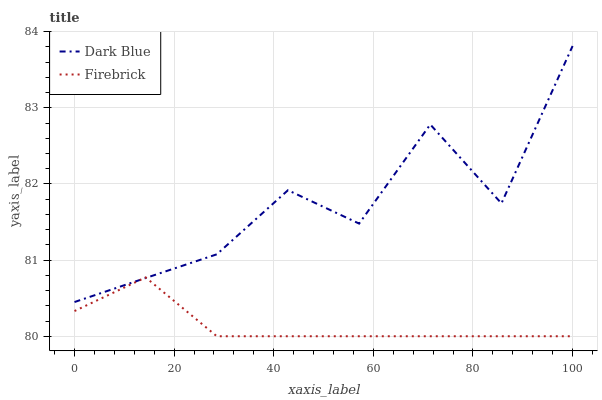Does Firebrick have the minimum area under the curve?
Answer yes or no. Yes. Does Dark Blue have the maximum area under the curve?
Answer yes or no. Yes. Does Firebrick have the maximum area under the curve?
Answer yes or no. No. Is Firebrick the smoothest?
Answer yes or no. Yes. Is Dark Blue the roughest?
Answer yes or no. Yes. Is Firebrick the roughest?
Answer yes or no. No. Does Firebrick have the lowest value?
Answer yes or no. Yes. Does Dark Blue have the highest value?
Answer yes or no. Yes. Does Firebrick have the highest value?
Answer yes or no. No. Does Dark Blue intersect Firebrick?
Answer yes or no. Yes. Is Dark Blue less than Firebrick?
Answer yes or no. No. Is Dark Blue greater than Firebrick?
Answer yes or no. No. 